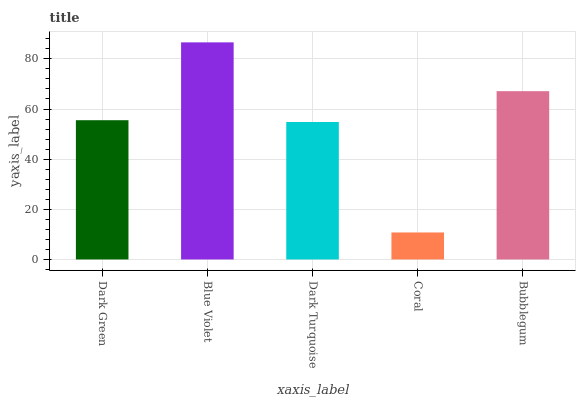Is Dark Turquoise the minimum?
Answer yes or no. No. Is Dark Turquoise the maximum?
Answer yes or no. No. Is Blue Violet greater than Dark Turquoise?
Answer yes or no. Yes. Is Dark Turquoise less than Blue Violet?
Answer yes or no. Yes. Is Dark Turquoise greater than Blue Violet?
Answer yes or no. No. Is Blue Violet less than Dark Turquoise?
Answer yes or no. No. Is Dark Green the high median?
Answer yes or no. Yes. Is Dark Green the low median?
Answer yes or no. Yes. Is Dark Turquoise the high median?
Answer yes or no. No. Is Bubblegum the low median?
Answer yes or no. No. 